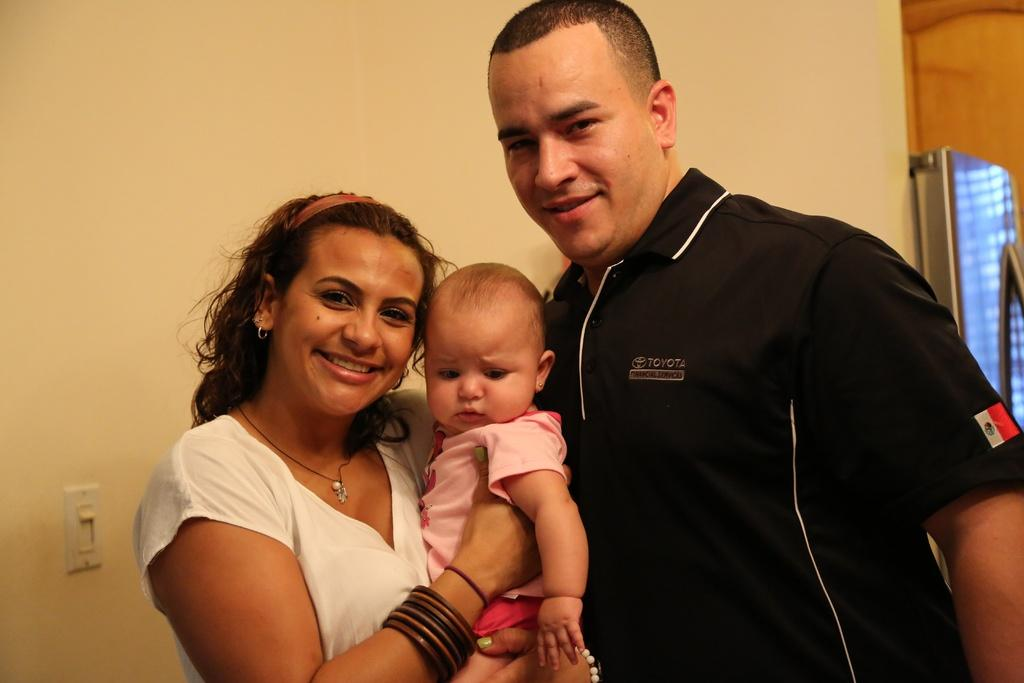<image>
Describe the image concisely. A man, with a black shirt by Toyota, and his wife posing with their child. 